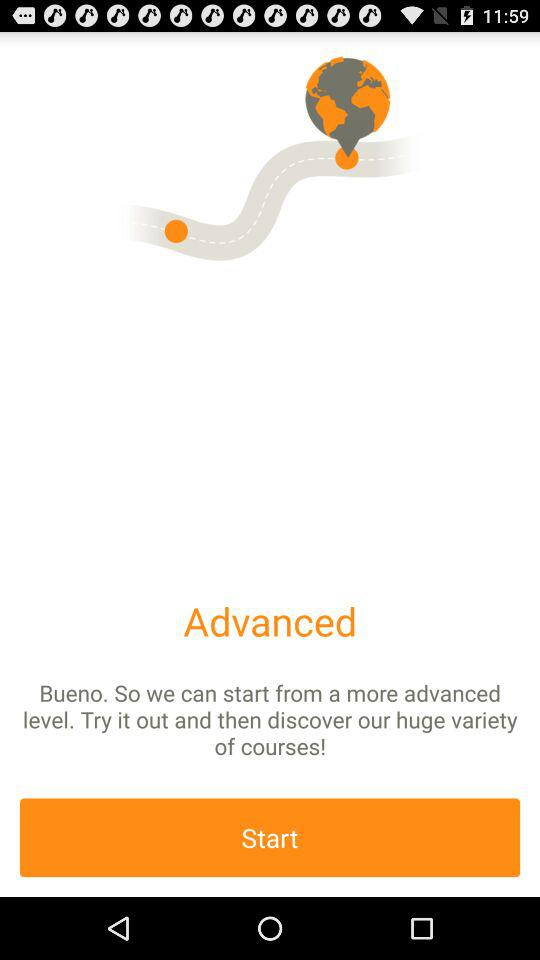What level is selected? The selected level is "advanced". 